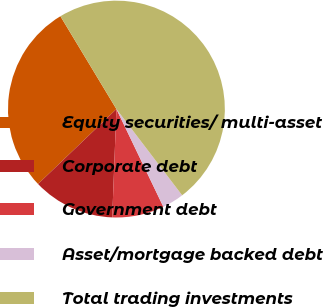<chart> <loc_0><loc_0><loc_500><loc_500><pie_chart><fcel>Equity securities/ multi-asset<fcel>Corporate debt<fcel>Government debt<fcel>Asset/mortgage backed debt<fcel>Total trading investments<nl><fcel>28.5%<fcel>12.24%<fcel>7.74%<fcel>3.24%<fcel>48.27%<nl></chart> 